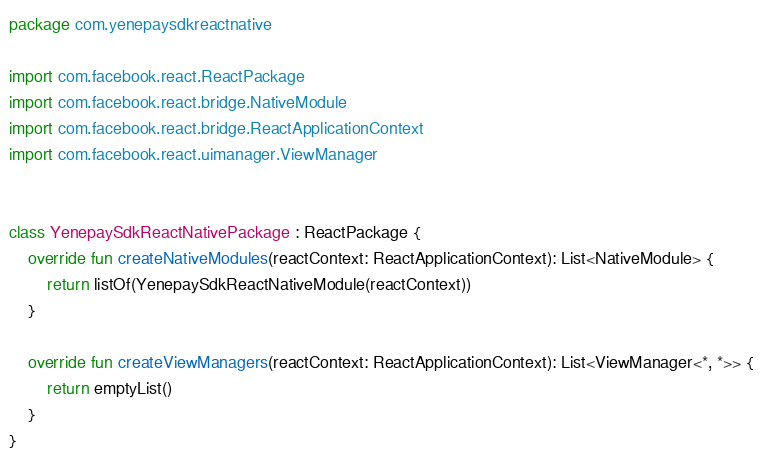<code> <loc_0><loc_0><loc_500><loc_500><_Kotlin_>package com.yenepaysdkreactnative

import com.facebook.react.ReactPackage
import com.facebook.react.bridge.NativeModule
import com.facebook.react.bridge.ReactApplicationContext
import com.facebook.react.uimanager.ViewManager


class YenepaySdkReactNativePackage : ReactPackage {
    override fun createNativeModules(reactContext: ReactApplicationContext): List<NativeModule> {
        return listOf(YenepaySdkReactNativeModule(reactContext))
    }

    override fun createViewManagers(reactContext: ReactApplicationContext): List<ViewManager<*, *>> {
        return emptyList()
    }
}
</code> 